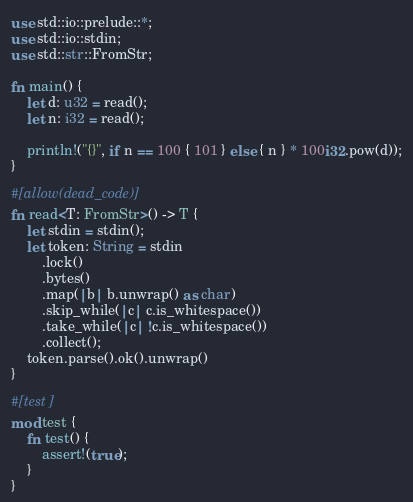Convert code to text. <code><loc_0><loc_0><loc_500><loc_500><_Rust_>use std::io::prelude::*;
use std::io::stdin;
use std::str::FromStr;

fn main() {
    let d: u32 = read();
    let n: i32 = read();

    println!("{}", if n == 100 { 101 } else { n } * 100i32.pow(d));
}

#[allow(dead_code)]
fn read<T: FromStr>() -> T {
    let stdin = stdin();
    let token: String = stdin
        .lock()
        .bytes()
        .map(|b| b.unwrap() as char)
        .skip_while(|c| c.is_whitespace())
        .take_while(|c| !c.is_whitespace())
        .collect();
    token.parse().ok().unwrap()
}

#[test]
mod test {
    fn test() {
        assert!(true);
    }
}
</code> 